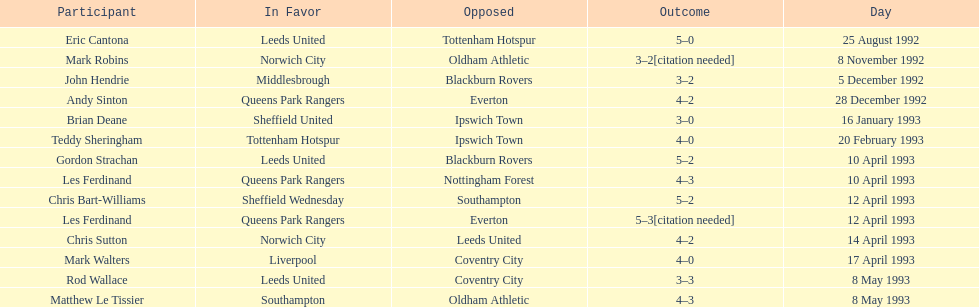How many players were for leeds united? 3. 